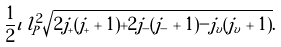Convert formula to latex. <formula><loc_0><loc_0><loc_500><loc_500>\frac { 1 } { 2 } \iota \, l _ { P } ^ { 2 } \sqrt { 2 j _ { + } ( j _ { + } + 1 ) + 2 j _ { - } ( j _ { - } + 1 ) - j _ { v } ( j _ { v } + 1 ) } .</formula> 